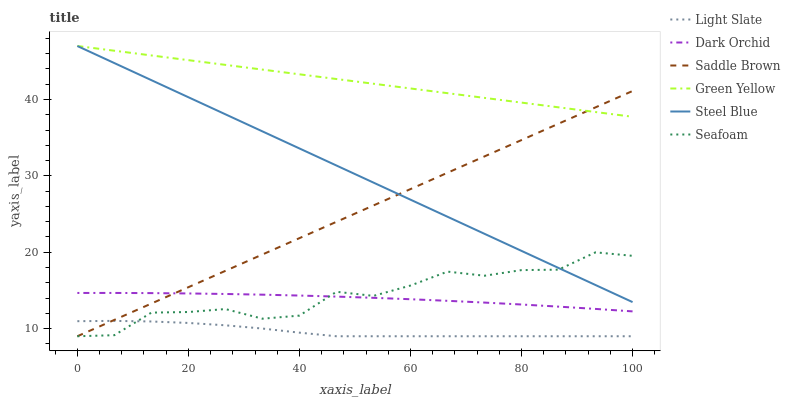Does Light Slate have the minimum area under the curve?
Answer yes or no. Yes. Does Green Yellow have the maximum area under the curve?
Answer yes or no. Yes. Does Seafoam have the minimum area under the curve?
Answer yes or no. No. Does Seafoam have the maximum area under the curve?
Answer yes or no. No. Is Saddle Brown the smoothest?
Answer yes or no. Yes. Is Seafoam the roughest?
Answer yes or no. Yes. Is Dark Orchid the smoothest?
Answer yes or no. No. Is Dark Orchid the roughest?
Answer yes or no. No. Does Light Slate have the lowest value?
Answer yes or no. Yes. Does Dark Orchid have the lowest value?
Answer yes or no. No. Does Green Yellow have the highest value?
Answer yes or no. Yes. Does Seafoam have the highest value?
Answer yes or no. No. Is Seafoam less than Green Yellow?
Answer yes or no. Yes. Is Dark Orchid greater than Light Slate?
Answer yes or no. Yes. Does Seafoam intersect Steel Blue?
Answer yes or no. Yes. Is Seafoam less than Steel Blue?
Answer yes or no. No. Is Seafoam greater than Steel Blue?
Answer yes or no. No. Does Seafoam intersect Green Yellow?
Answer yes or no. No. 